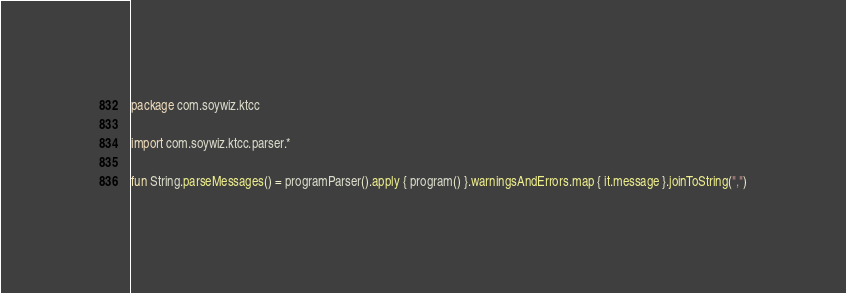<code> <loc_0><loc_0><loc_500><loc_500><_Kotlin_>package com.soywiz.ktcc

import com.soywiz.ktcc.parser.*

fun String.parseMessages() = programParser().apply { program() }.warningsAndErrors.map { it.message }.joinToString(",")
</code> 